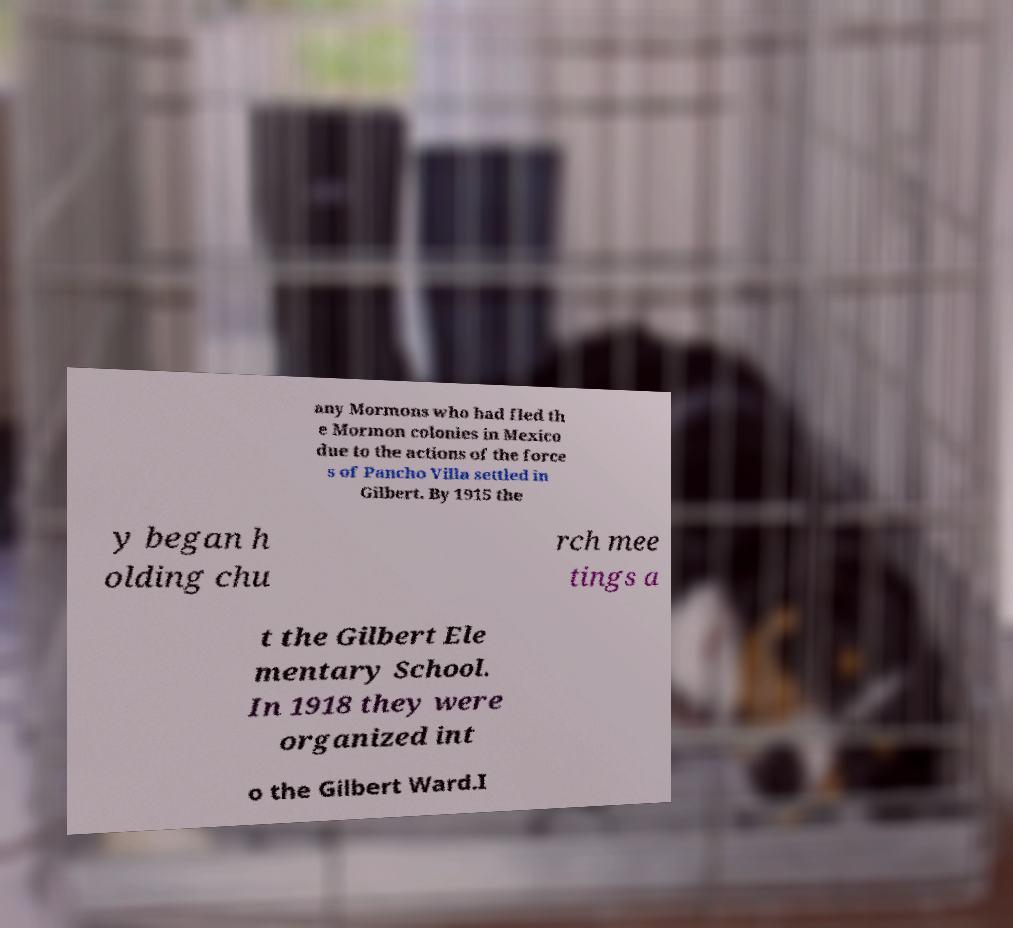Could you assist in decoding the text presented in this image and type it out clearly? any Mormons who had fled th e Mormon colonies in Mexico due to the actions of the force s of Pancho Villa settled in Gilbert. By 1915 the y began h olding chu rch mee tings a t the Gilbert Ele mentary School. In 1918 they were organized int o the Gilbert Ward.I 